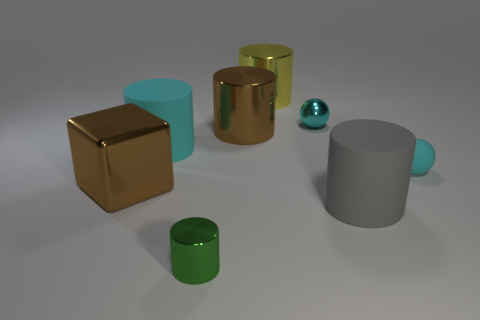Subtract all yellow cylinders. How many cylinders are left? 4 Add 1 green objects. How many objects exist? 9 Subtract all spheres. How many objects are left? 6 Subtract 0 red blocks. How many objects are left? 8 Subtract all small green metal objects. Subtract all big gray rubber cylinders. How many objects are left? 6 Add 3 green shiny cylinders. How many green shiny cylinders are left? 4 Add 8 large gray spheres. How many large gray spheres exist? 8 